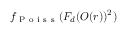Convert formula to latex. <formula><loc_0><loc_0><loc_500><loc_500>f _ { P o i s s } ( F _ { d } ( O ( r ) ) ^ { 2 } )</formula> 